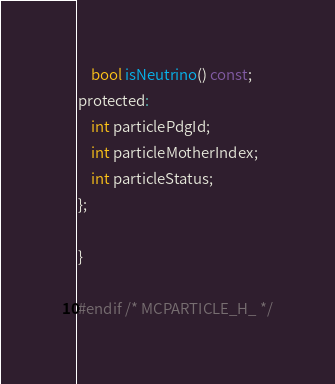<code> <loc_0><loc_0><loc_500><loc_500><_C_>	bool isNeutrino() const;
protected:
	int particlePdgId;
	int particleMotherIndex;
	int particleStatus;
};

}

#endif /* MCPARTICLE_H_ */
</code> 